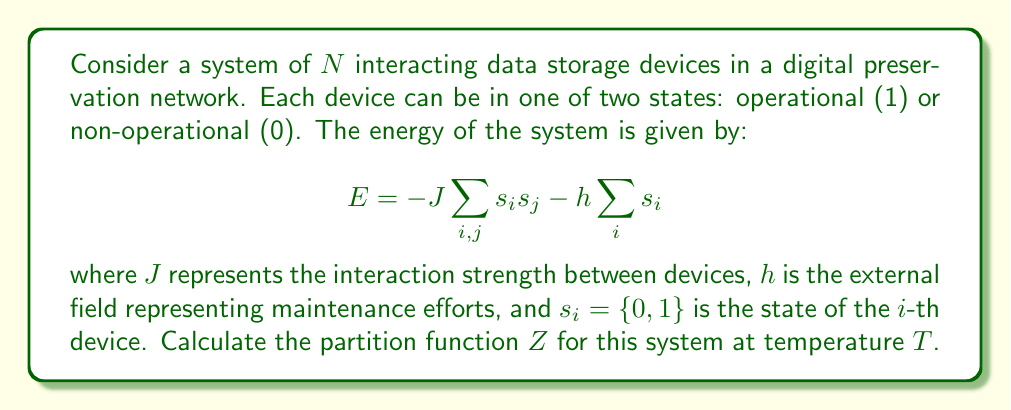Give your solution to this math problem. To calculate the partition function, we follow these steps:

1) The partition function is defined as:
   $$Z = \sum_{\text{all states}} e^{-\beta E}$$
   where $\beta = \frac{1}{k_B T}$, $k_B$ is Boltzmann's constant, and $T$ is temperature.

2) Substituting the energy expression:
   $$Z = \sum_{\{s_i\}} \exp\left(\beta J\sum_{i,j} s_i s_j + \beta h\sum_i s_i\right)$$

3) This system is analogous to the Ising model in statistical mechanics. For a large system, we can use the mean-field approximation:
   $$\sum_{i,j} s_i s_j \approx N^2 m^2$$
   where $m = \frac{1}{N}\sum_i s_i$ is the average state of the devices.

4) The partition function becomes:
   $$Z \approx \sum_{\{s_i\}} \exp\left(\beta J N^2 m^2 + \beta h N m\right)$$

5) In the thermodynamic limit (large $N$), we can use the saddle-point approximation:
   $$Z \approx \exp\left(N\max_m[J N m^2 + h m + \frac{1}{\beta} S(m)]\right)$$
   where $S(m)$ is the entropy per device.

6) For a two-state system, the entropy is:
   $$S(m) = -\frac{1+m}{2}\ln\left(\frac{1+m}{2}\right) - \frac{1-m}{2}\ln\left(\frac{1-m}{2}\right)$$

7) Therefore, the final form of the partition function is:
   $$Z \approx \exp\left(N\max_m\left[J N m^2 + h m - \frac{1}{\beta}\left(\frac{1+m}{2}\ln\left(\frac{1+m}{2}\right) + \frac{1-m}{2}\ln\left(\frac{1-m}{2}\right)\right)\right]\right)$$
Answer: $$Z \approx \exp\left(N\max_m\left[J N m^2 + h m - \frac{1}{\beta}\left(\frac{1+m}{2}\ln\left(\frac{1+m}{2}\right) + \frac{1-m}{2}\ln\left(\frac{1-m}{2}\right)\right)\right]\right)$$ 